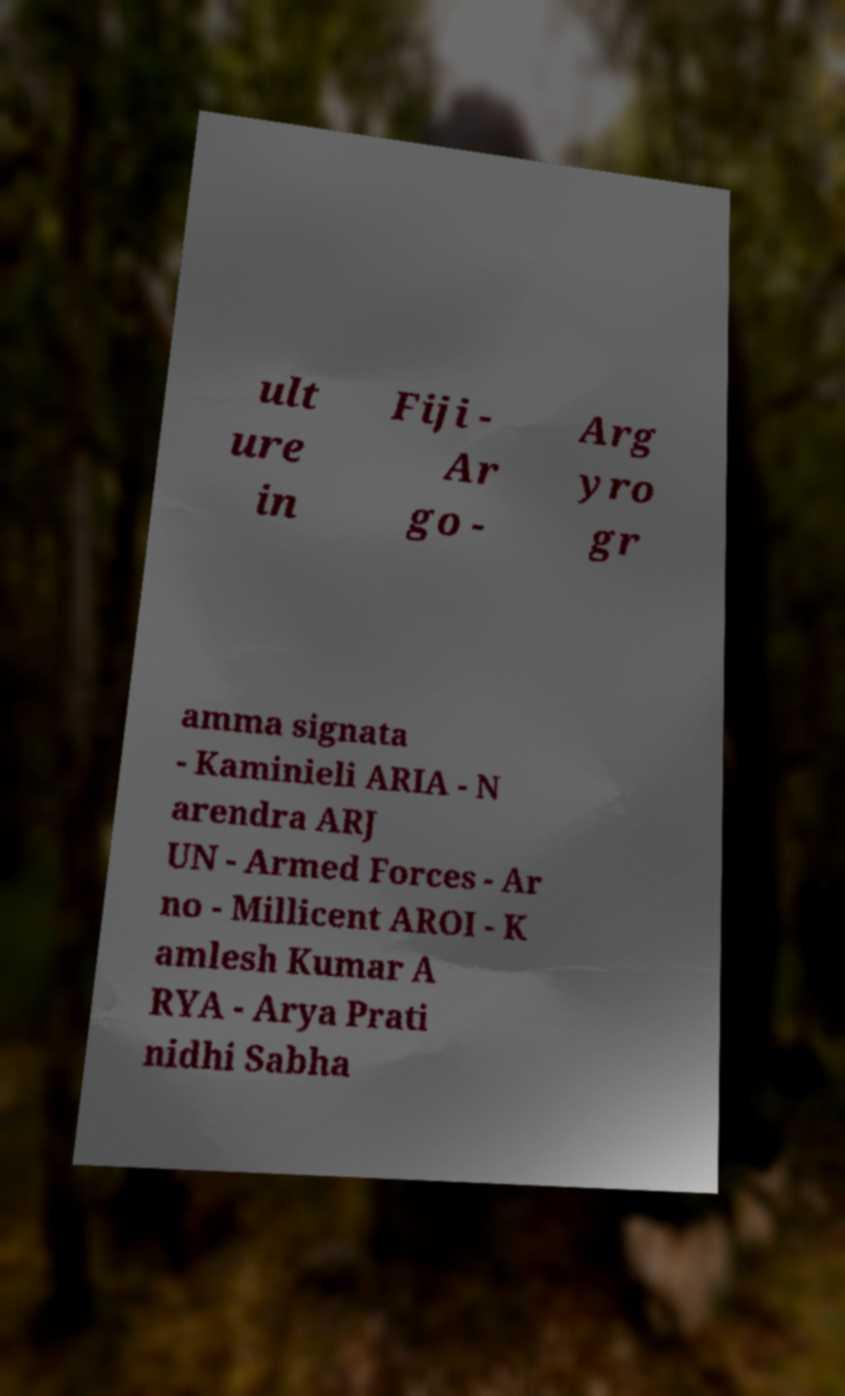I need the written content from this picture converted into text. Can you do that? ult ure in Fiji - Ar go - Arg yro gr amma signata - Kaminieli ARIA - N arendra ARJ UN - Armed Forces - Ar no - Millicent AROI - K amlesh Kumar A RYA - Arya Prati nidhi Sabha 